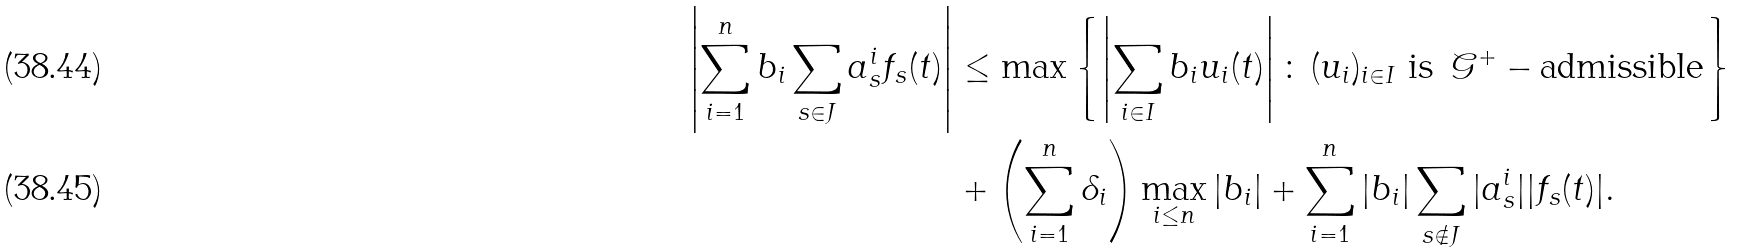<formula> <loc_0><loc_0><loc_500><loc_500>\left | \sum _ { i = 1 } ^ { n } b _ { i } \sum _ { s \in J } a _ { s } ^ { i } f _ { s } ( t ) \right | & \leq \max \left \{ \left | \sum _ { i \in I } b _ { i } u _ { i } ( t ) \right | \colon \, ( u _ { i } ) _ { i \in I } \text { is } \, \mathcal { G } ^ { + } - \text {admissible} \right \} \\ & + \left ( \sum _ { i = 1 } ^ { n } \delta _ { i } \right ) \max _ { i \leq n } | b _ { i } | + \sum _ { i = 1 } ^ { n } | b _ { i } | \sum _ { s \notin J } | a _ { s } ^ { i } | | f _ { s } ( t ) | .</formula> 